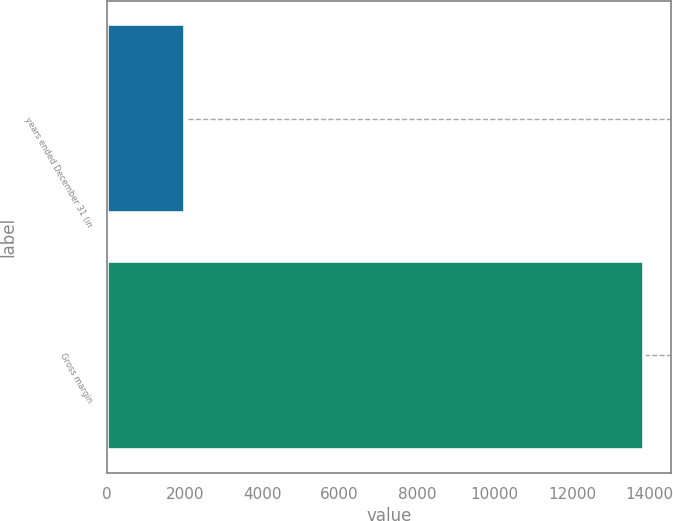Convert chart to OTSL. <chart><loc_0><loc_0><loc_500><loc_500><bar_chart><fcel>years ended December 31 (in<fcel>Gross margin<nl><fcel>2012<fcel>13872<nl></chart> 